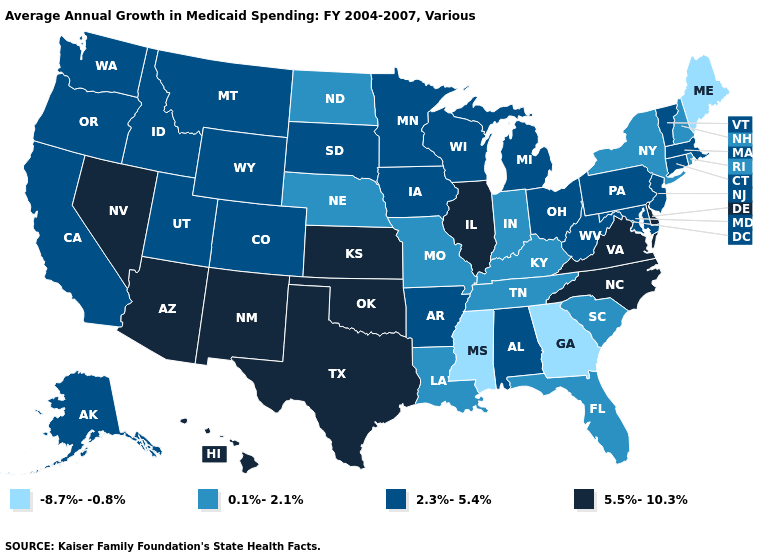Name the states that have a value in the range -8.7%--0.8%?
Be succinct. Georgia, Maine, Mississippi. Does Maryland have the same value as Florida?
Short answer required. No. Name the states that have a value in the range 5.5%-10.3%?
Concise answer only. Arizona, Delaware, Hawaii, Illinois, Kansas, Nevada, New Mexico, North Carolina, Oklahoma, Texas, Virginia. What is the highest value in states that border Delaware?
Write a very short answer. 2.3%-5.4%. What is the value of Rhode Island?
Be succinct. 0.1%-2.1%. Does Kansas have the same value as Arizona?
Keep it brief. Yes. Does Arizona have the highest value in the West?
Short answer required. Yes. Which states have the lowest value in the USA?
Write a very short answer. Georgia, Maine, Mississippi. Name the states that have a value in the range 5.5%-10.3%?
Quick response, please. Arizona, Delaware, Hawaii, Illinois, Kansas, Nevada, New Mexico, North Carolina, Oklahoma, Texas, Virginia. Does the map have missing data?
Be succinct. No. Name the states that have a value in the range 5.5%-10.3%?
Short answer required. Arizona, Delaware, Hawaii, Illinois, Kansas, Nevada, New Mexico, North Carolina, Oklahoma, Texas, Virginia. Is the legend a continuous bar?
Quick response, please. No. Name the states that have a value in the range 0.1%-2.1%?
Be succinct. Florida, Indiana, Kentucky, Louisiana, Missouri, Nebraska, New Hampshire, New York, North Dakota, Rhode Island, South Carolina, Tennessee. Does Arizona have the same value as Washington?
Short answer required. No. Among the states that border Arizona , does Colorado have the lowest value?
Write a very short answer. Yes. 